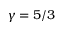Convert formula to latex. <formula><loc_0><loc_0><loc_500><loc_500>\gamma = 5 / 3</formula> 